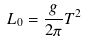Convert formula to latex. <formula><loc_0><loc_0><loc_500><loc_500>L _ { 0 } = \frac { g } { 2 \pi } T ^ { 2 }</formula> 